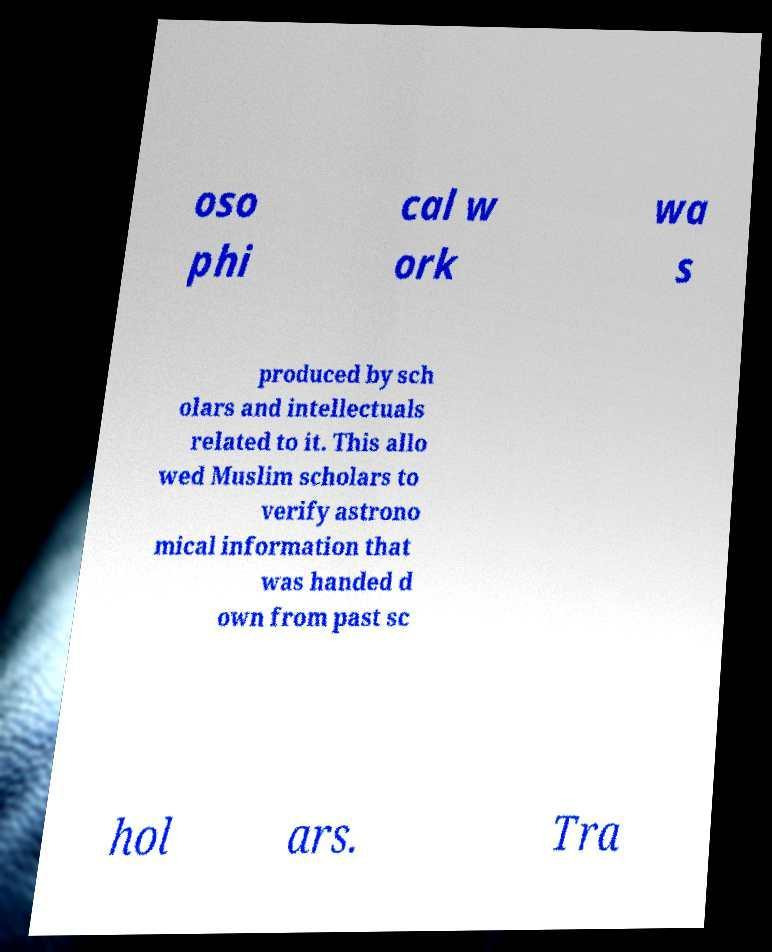I need the written content from this picture converted into text. Can you do that? oso phi cal w ork wa s produced by sch olars and intellectuals related to it. This allo wed Muslim scholars to verify astrono mical information that was handed d own from past sc hol ars. Tra 